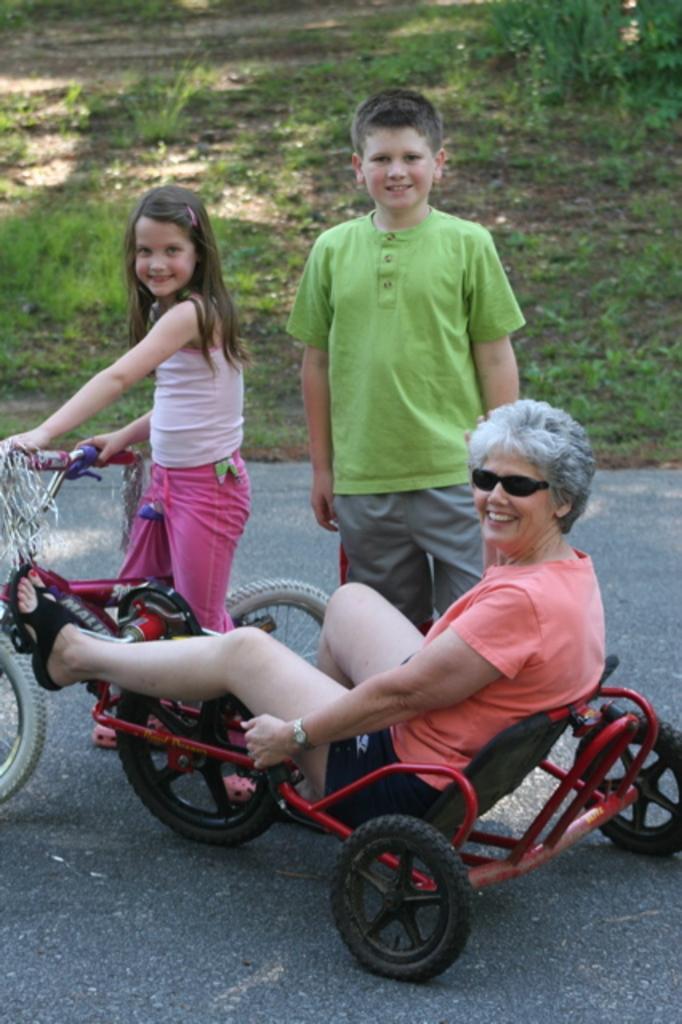In one or two sentences, can you explain what this image depicts? In this picture a person sitting on a wheelchair and he is smiling. There is a girl and she is sitting on a bicycle and she is smiling as well. There is a boy on the right side. 